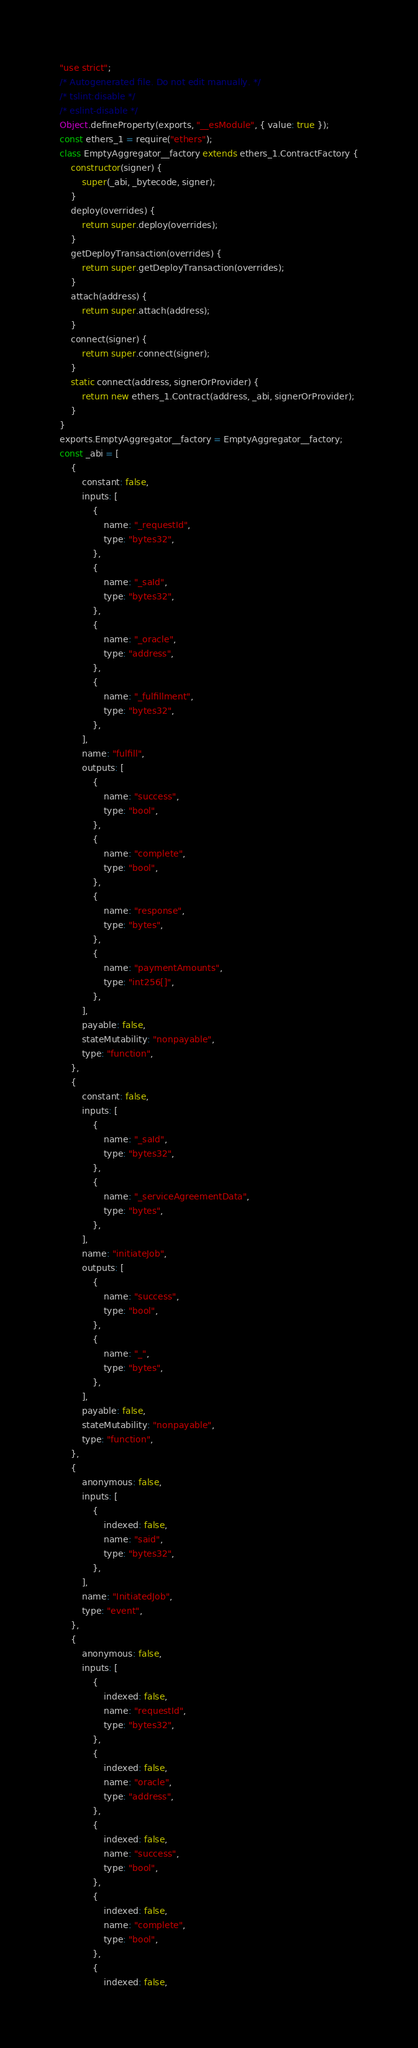<code> <loc_0><loc_0><loc_500><loc_500><_JavaScript_>"use strict";
/* Autogenerated file. Do not edit manually. */
/* tslint:disable */
/* eslint-disable */
Object.defineProperty(exports, "__esModule", { value: true });
const ethers_1 = require("ethers");
class EmptyAggregator__factory extends ethers_1.ContractFactory {
    constructor(signer) {
        super(_abi, _bytecode, signer);
    }
    deploy(overrides) {
        return super.deploy(overrides);
    }
    getDeployTransaction(overrides) {
        return super.getDeployTransaction(overrides);
    }
    attach(address) {
        return super.attach(address);
    }
    connect(signer) {
        return super.connect(signer);
    }
    static connect(address, signerOrProvider) {
        return new ethers_1.Contract(address, _abi, signerOrProvider);
    }
}
exports.EmptyAggregator__factory = EmptyAggregator__factory;
const _abi = [
    {
        constant: false,
        inputs: [
            {
                name: "_requestId",
                type: "bytes32",
            },
            {
                name: "_saId",
                type: "bytes32",
            },
            {
                name: "_oracle",
                type: "address",
            },
            {
                name: "_fulfillment",
                type: "bytes32",
            },
        ],
        name: "fulfill",
        outputs: [
            {
                name: "success",
                type: "bool",
            },
            {
                name: "complete",
                type: "bool",
            },
            {
                name: "response",
                type: "bytes",
            },
            {
                name: "paymentAmounts",
                type: "int256[]",
            },
        ],
        payable: false,
        stateMutability: "nonpayable",
        type: "function",
    },
    {
        constant: false,
        inputs: [
            {
                name: "_saId",
                type: "bytes32",
            },
            {
                name: "_serviceAgreementData",
                type: "bytes",
            },
        ],
        name: "initiateJob",
        outputs: [
            {
                name: "success",
                type: "bool",
            },
            {
                name: "_",
                type: "bytes",
            },
        ],
        payable: false,
        stateMutability: "nonpayable",
        type: "function",
    },
    {
        anonymous: false,
        inputs: [
            {
                indexed: false,
                name: "said",
                type: "bytes32",
            },
        ],
        name: "InitiatedJob",
        type: "event",
    },
    {
        anonymous: false,
        inputs: [
            {
                indexed: false,
                name: "requestId",
                type: "bytes32",
            },
            {
                indexed: false,
                name: "oracle",
                type: "address",
            },
            {
                indexed: false,
                name: "success",
                type: "bool",
            },
            {
                indexed: false,
                name: "complete",
                type: "bool",
            },
            {
                indexed: false,</code> 